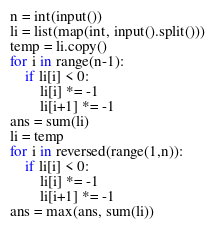Convert code to text. <code><loc_0><loc_0><loc_500><loc_500><_Python_>n = int(input())
li = list(map(int, input().split()))
temp = li.copy()
for i in range(n-1):
    if li[i] < 0:
        li[i] *= -1
        li[i+1] *= -1
ans = sum(li)
li = temp
for i in reversed(range(1,n)):
    if li[i] < 0:
        li[i] *= -1
        li[i+1] *= -1
ans = max(ans, sum(li))</code> 